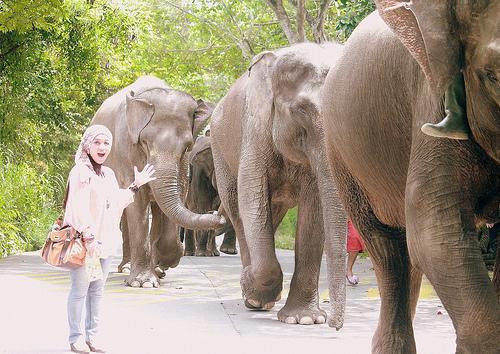How many elephants are there?
Give a very brief answer. 4. 